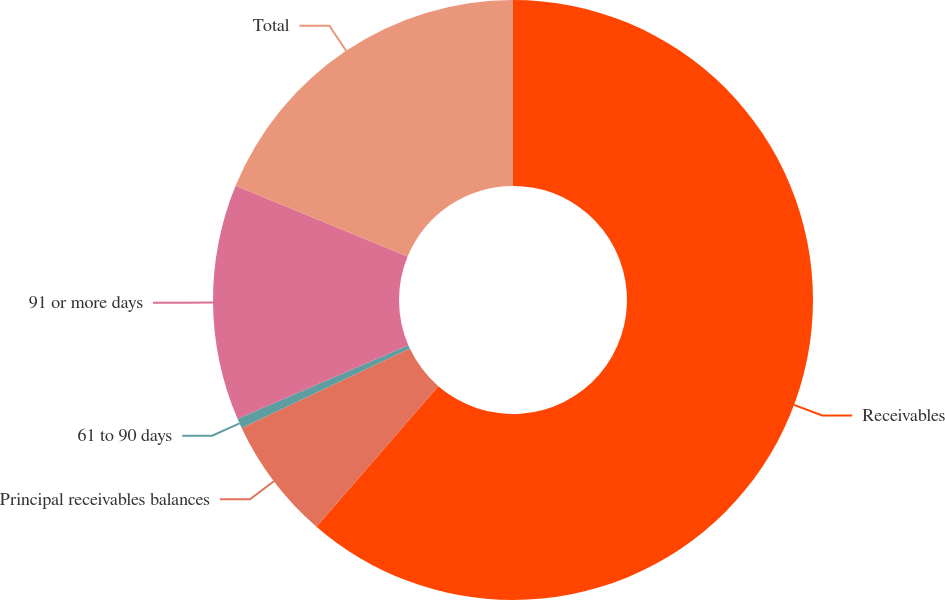<chart> <loc_0><loc_0><loc_500><loc_500><pie_chart><fcel>Receivables<fcel>Principal receivables balances<fcel>61 to 90 days<fcel>91 or more days<fcel>Total<nl><fcel>61.37%<fcel>6.62%<fcel>0.53%<fcel>12.7%<fcel>18.78%<nl></chart> 